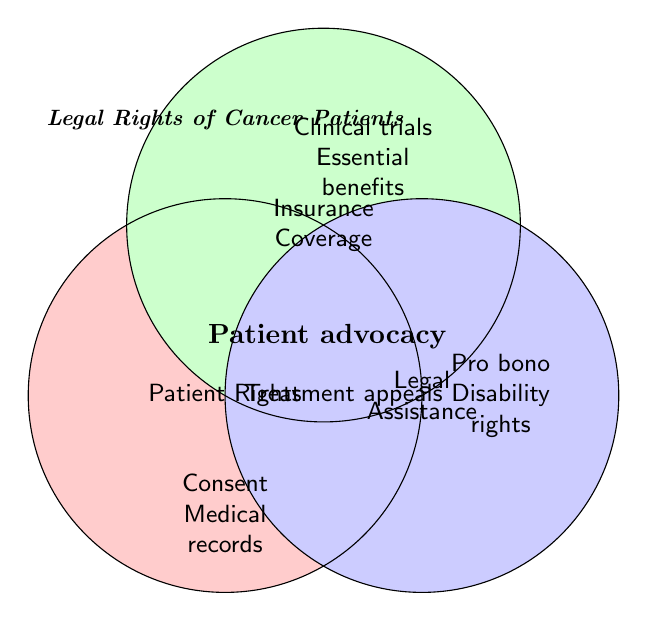What is the title of the Venn Diagram? The title is written at the top of the diagram in italics and specifies the subject of the figure. In this case, it states "Legal Rights of Cancer Patients".
Answer: Legal Rights of Cancer Patients Which sections of the Venn Diagram pertain to insurance coverage? To determine the sections related to insurance coverage, we look for the circle labeled "Insurance Coverage" and the areas it overlaps with other circles. Insurance-related sections include "Clinical trials Essential benefits", "Pro bono Disability rights", and the intersection "Patient advocacy", "Treatment appeals".
Answer: Clinical trials Essential benefits, Pro bono Disability rights, Patient advocacy, Treatment appeals How many unique aspects are listed in the 'Patient Rights' circle? The 'Patient Rights' circle is shaded red and includes the items listed within its boundary. The unique aspects are "Consent Medical records", "Pain management", and "Palliative care".
Answer: 3 What is the common aspect in the intersection of all three circles? The common aspect is identified at the center where all three circles overlap. The text "Patient advocacy" is located there.
Answer: Patient advocacy Which area covers 'Treatment appeals'? The label "Treatment appeals" is found in the area where both 'Insurance Coverage' and 'Legal Assistance' circles intersect.
Answer: In the intersection of 'Insurance Coverage' and 'Legal Assistance' Is "Disability rights" included under 'Patient Rights'? To check this, locate "Disability rights" in the Venn Diagram. It is found in the 'Legal Assistance' circle, and not in the 'Patient Rights' circle.
Answer: No What are the shared aspects between 'Patient Rights' and 'Insurance Coverage'? The shared aspects are found in the overlapping area of these two circles. The Venn Diagram shows "Consent Medical records" and "Clinical trials Essential benefits" in this overlap.
Answer: Consent Medical records, Clinical trials Essential benefits How many aspects are unique to 'Legal Assistance'? Count the aspects solely within the 'Legal Assistance' circle. These are "Pro bono Disability rights" and "Malpractice claims".
Answer: 2 Which shared feature between 'Patient Rights' and 'Legal Assistance' is involved in clinical trials? 'Clinical trials' relates to the intersection of interests involving 'Insurance Coverage'. The correct feature connected to clinical trials is "Clinical trials Essential benefits".
Answer: Clinical trials Essential benefits 